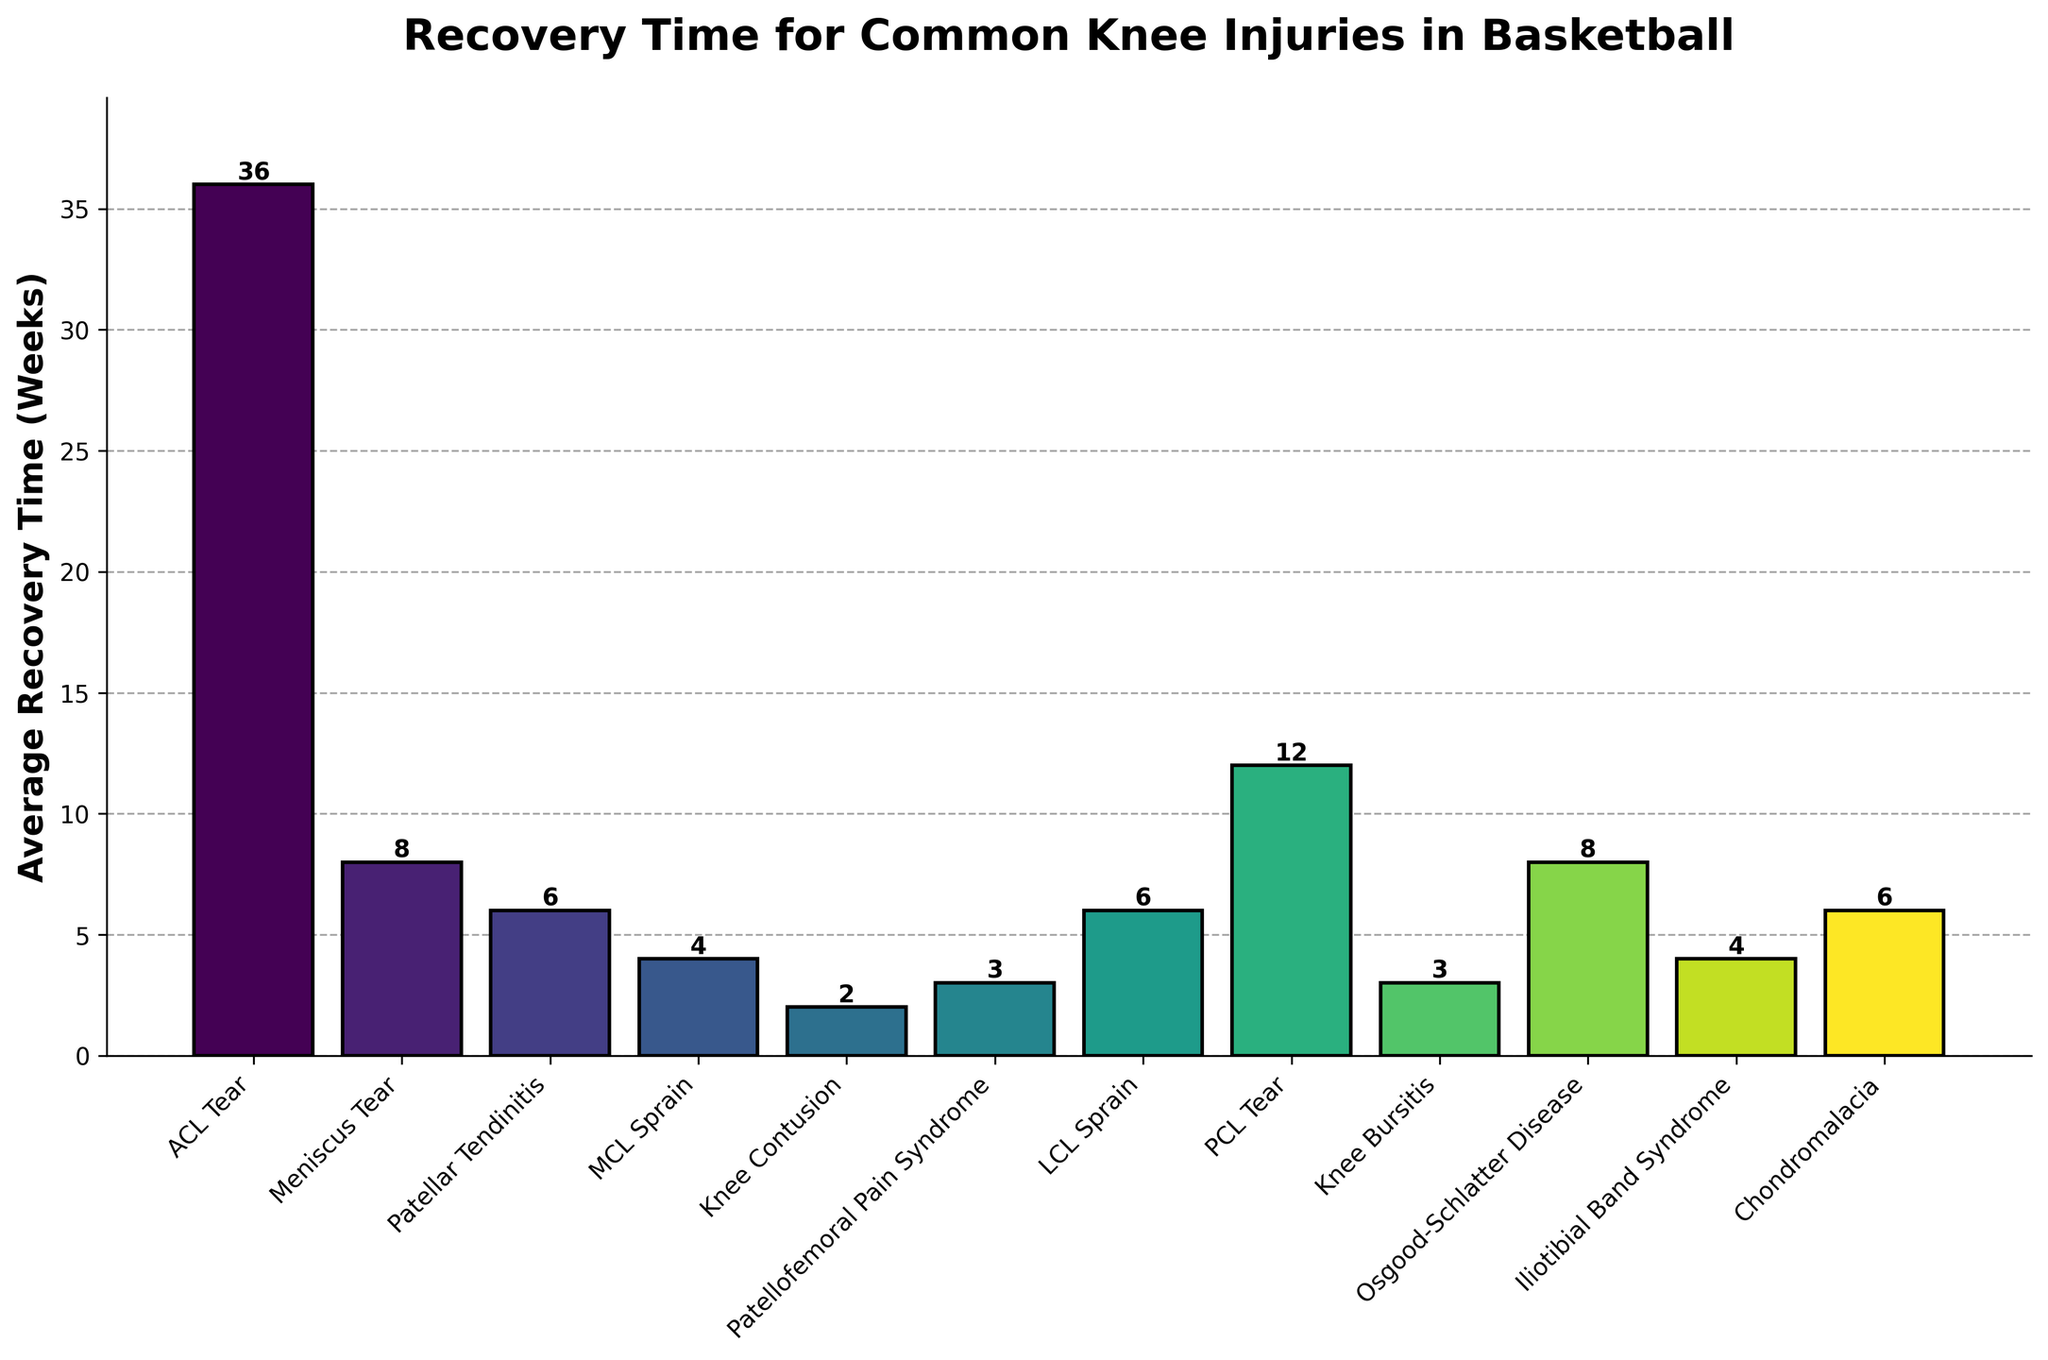Which knee injury has the longest average recovery time? Look at the highest bar on the graph, which represents the injury type with the longest recovery time.
Answer: ACL Tear Which knee injuries have an average recovery time of more than 10 weeks? Identify bars that reach or exceed the 10-week mark on the y-axis of the graph.
Answer: ACL Tear, PCL Tear What is the combined recovery time for Meniscus Tear and Osgood-Schlatter Disease? Find the heights of the bars for Meniscus Tear (8 weeks) and Osgood-Schlatter Disease (8 weeks) and add them together, 8 + 8 = 16 weeks.
Answer: 16 weeks Which injury types have the same average recovery time? Locate bars of equal height and note their respective injury types.
Answer: Patellar Tendinitis, LCL Sprain, Chondromalacia (6 weeks each), Patellofemoral Pain Syndrome, Knee Bursitis (3 weeks each) How many injury types have a recovery time of 6 weeks? Count the bars that reach exactly 6 weeks on the y-axis.
Answer: 3 Which injury has a shorter recovery time, Iliotibial Band Syndrome or MCL Sprain? Compare the heights of the bars for Iliotibial Band Syndrome (4 weeks) and MCL Sprain (4 weeks).
Answer: They both have equal recovery times How much longer is the recovery time for an ACL Tear compared to a Knee Contusion? Find the heights of the bars for ACL Tear (36 weeks) and Knee Contusion (2 weeks) and subtract the latter from the former, 36 - 2 = 34 weeks.
Answer: 34 weeks Are there more injury types with a recovery time of less than 6 weeks or more than 6 weeks? Count the number of bars less than and more than 6 weeks. Less than: 5 (MCL Sprain, Knee Contusion, Patellofemoral Pain Syndrome, Knee Bursitis, Iliotibial Band Syndrome). More than: 4 (ACL Tear, PCL Tear, Meniscus Tear, Osgood-Schlatter Disease).
Answer: Less than Which injury type has a recovery time closest to 5 weeks? Find the bar with a height closest to 5 on the y-axis.
Answer: Iliotibial Band Syndrome, MCL Sprain (both 4 weeks) What is the median recovery time for all listed knee injuries? List the recovery times in ascending order: 2, 3, 3, 4, 4, 6, 6, 6, 8, 8, 12, 36. The median will be the average of the 6th and 7th values: (6 + 6)/2 = 6 weeks.
Answer: 6 weeks 